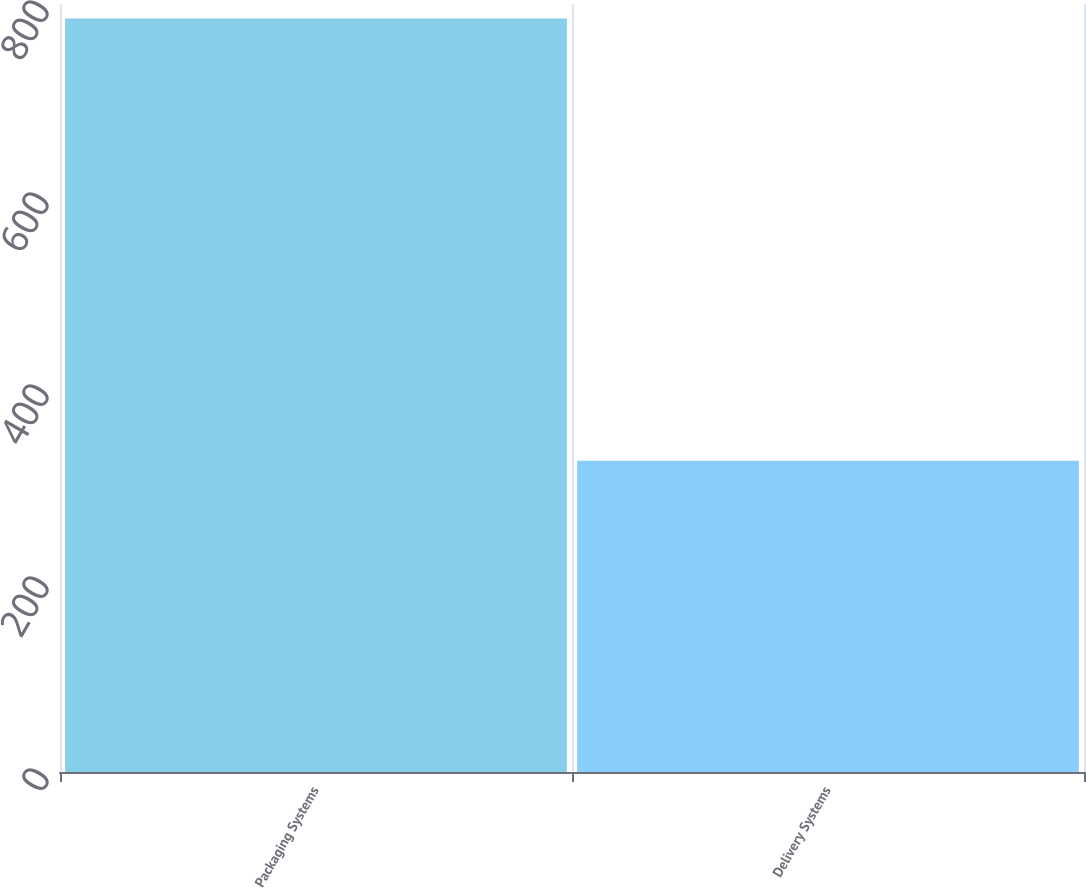Convert chart. <chart><loc_0><loc_0><loc_500><loc_500><bar_chart><fcel>Packaging Systems<fcel>Delivery Systems<nl><fcel>785<fcel>324.1<nl></chart> 